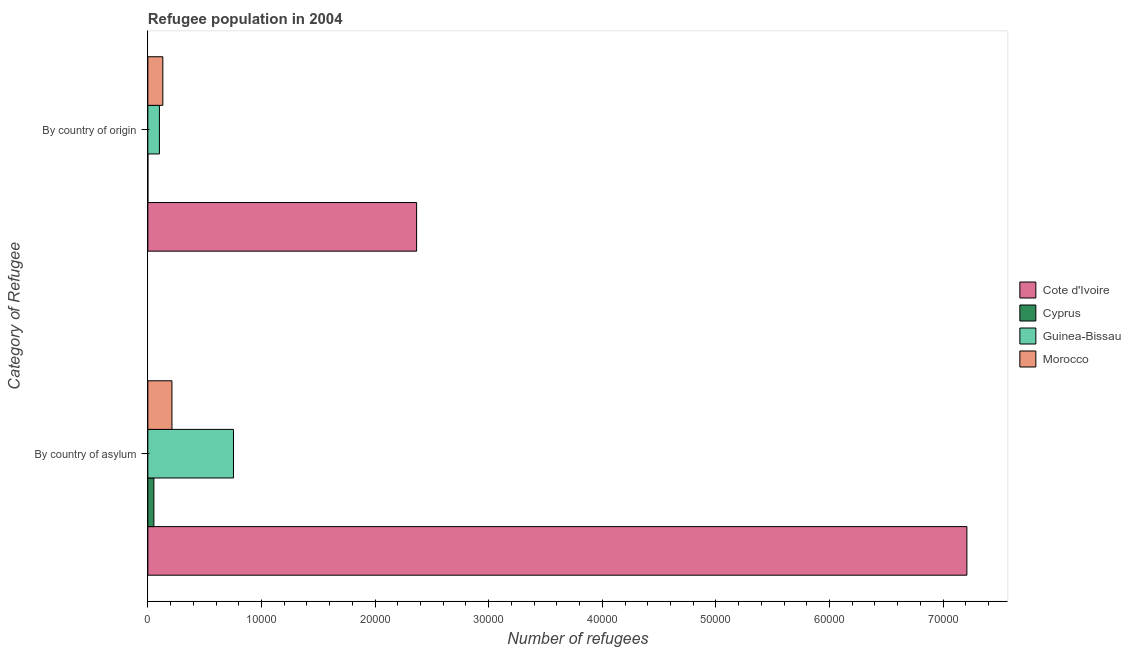How many groups of bars are there?
Keep it short and to the point. 2. What is the label of the 2nd group of bars from the top?
Give a very brief answer. By country of asylum. What is the number of refugees by country of origin in Guinea-Bissau?
Provide a succinct answer. 1018. Across all countries, what is the maximum number of refugees by country of origin?
Your answer should be very brief. 2.37e+04. Across all countries, what is the minimum number of refugees by country of asylum?
Give a very brief answer. 531. In which country was the number of refugees by country of origin maximum?
Your response must be concise. Cote d'Ivoire. In which country was the number of refugees by country of origin minimum?
Your answer should be compact. Cyprus. What is the total number of refugees by country of asylum in the graph?
Make the answer very short. 8.23e+04. What is the difference between the number of refugees by country of asylum in Morocco and that in Guinea-Bissau?
Keep it short and to the point. -5415. What is the difference between the number of refugees by country of asylum in Cyprus and the number of refugees by country of origin in Cote d'Ivoire?
Give a very brief answer. -2.31e+04. What is the average number of refugees by country of origin per country?
Make the answer very short. 6498.5. What is the difference between the number of refugees by country of origin and number of refugees by country of asylum in Guinea-Bissau?
Offer a terse response. -6518. What is the ratio of the number of refugees by country of origin in Cyprus to that in Morocco?
Make the answer very short. 0. Is the number of refugees by country of origin in Cote d'Ivoire less than that in Morocco?
Keep it short and to the point. No. In how many countries, is the number of refugees by country of origin greater than the average number of refugees by country of origin taken over all countries?
Give a very brief answer. 1. What does the 3rd bar from the top in By country of origin represents?
Offer a very short reply. Cyprus. What does the 3rd bar from the bottom in By country of asylum represents?
Provide a short and direct response. Guinea-Bissau. Does the graph contain any zero values?
Ensure brevity in your answer.  No. How many legend labels are there?
Offer a terse response. 4. What is the title of the graph?
Your answer should be very brief. Refugee population in 2004. Does "North America" appear as one of the legend labels in the graph?
Keep it short and to the point. No. What is the label or title of the X-axis?
Provide a short and direct response. Number of refugees. What is the label or title of the Y-axis?
Provide a short and direct response. Category of Refugee. What is the Number of refugees of Cote d'Ivoire in By country of asylum?
Offer a very short reply. 7.21e+04. What is the Number of refugees of Cyprus in By country of asylum?
Offer a very short reply. 531. What is the Number of refugees in Guinea-Bissau in By country of asylum?
Keep it short and to the point. 7536. What is the Number of refugees in Morocco in By country of asylum?
Provide a short and direct response. 2121. What is the Number of refugees of Cote d'Ivoire in By country of origin?
Ensure brevity in your answer.  2.37e+04. What is the Number of refugees in Guinea-Bissau in By country of origin?
Offer a very short reply. 1018. What is the Number of refugees of Morocco in By country of origin?
Your answer should be compact. 1319. Across all Category of Refugee, what is the maximum Number of refugees of Cote d'Ivoire?
Provide a succinct answer. 7.21e+04. Across all Category of Refugee, what is the maximum Number of refugees in Cyprus?
Offer a terse response. 531. Across all Category of Refugee, what is the maximum Number of refugees of Guinea-Bissau?
Ensure brevity in your answer.  7536. Across all Category of Refugee, what is the maximum Number of refugees in Morocco?
Provide a short and direct response. 2121. Across all Category of Refugee, what is the minimum Number of refugees of Cote d'Ivoire?
Your response must be concise. 2.37e+04. Across all Category of Refugee, what is the minimum Number of refugees of Guinea-Bissau?
Offer a very short reply. 1018. Across all Category of Refugee, what is the minimum Number of refugees of Morocco?
Your answer should be compact. 1319. What is the total Number of refugees in Cote d'Ivoire in the graph?
Make the answer very short. 9.57e+04. What is the total Number of refugees of Cyprus in the graph?
Your answer should be compact. 533. What is the total Number of refugees in Guinea-Bissau in the graph?
Provide a succinct answer. 8554. What is the total Number of refugees in Morocco in the graph?
Your answer should be compact. 3440. What is the difference between the Number of refugees in Cote d'Ivoire in By country of asylum and that in By country of origin?
Your response must be concise. 4.84e+04. What is the difference between the Number of refugees of Cyprus in By country of asylum and that in By country of origin?
Offer a terse response. 529. What is the difference between the Number of refugees of Guinea-Bissau in By country of asylum and that in By country of origin?
Offer a very short reply. 6518. What is the difference between the Number of refugees in Morocco in By country of asylum and that in By country of origin?
Give a very brief answer. 802. What is the difference between the Number of refugees in Cote d'Ivoire in By country of asylum and the Number of refugees in Cyprus in By country of origin?
Keep it short and to the point. 7.21e+04. What is the difference between the Number of refugees of Cote d'Ivoire in By country of asylum and the Number of refugees of Guinea-Bissau in By country of origin?
Provide a succinct answer. 7.11e+04. What is the difference between the Number of refugees in Cote d'Ivoire in By country of asylum and the Number of refugees in Morocco in By country of origin?
Offer a very short reply. 7.08e+04. What is the difference between the Number of refugees of Cyprus in By country of asylum and the Number of refugees of Guinea-Bissau in By country of origin?
Provide a short and direct response. -487. What is the difference between the Number of refugees of Cyprus in By country of asylum and the Number of refugees of Morocco in By country of origin?
Provide a succinct answer. -788. What is the difference between the Number of refugees of Guinea-Bissau in By country of asylum and the Number of refugees of Morocco in By country of origin?
Offer a terse response. 6217. What is the average Number of refugees of Cote d'Ivoire per Category of Refugee?
Provide a short and direct response. 4.79e+04. What is the average Number of refugees of Cyprus per Category of Refugee?
Provide a succinct answer. 266.5. What is the average Number of refugees of Guinea-Bissau per Category of Refugee?
Keep it short and to the point. 4277. What is the average Number of refugees in Morocco per Category of Refugee?
Give a very brief answer. 1720. What is the difference between the Number of refugees of Cote d'Ivoire and Number of refugees of Cyprus in By country of asylum?
Make the answer very short. 7.16e+04. What is the difference between the Number of refugees in Cote d'Ivoire and Number of refugees in Guinea-Bissau in By country of asylum?
Ensure brevity in your answer.  6.46e+04. What is the difference between the Number of refugees of Cote d'Ivoire and Number of refugees of Morocco in By country of asylum?
Your answer should be compact. 7.00e+04. What is the difference between the Number of refugees of Cyprus and Number of refugees of Guinea-Bissau in By country of asylum?
Offer a very short reply. -7005. What is the difference between the Number of refugees of Cyprus and Number of refugees of Morocco in By country of asylum?
Offer a terse response. -1590. What is the difference between the Number of refugees in Guinea-Bissau and Number of refugees in Morocco in By country of asylum?
Offer a terse response. 5415. What is the difference between the Number of refugees of Cote d'Ivoire and Number of refugees of Cyprus in By country of origin?
Make the answer very short. 2.37e+04. What is the difference between the Number of refugees in Cote d'Ivoire and Number of refugees in Guinea-Bissau in By country of origin?
Offer a very short reply. 2.26e+04. What is the difference between the Number of refugees in Cote d'Ivoire and Number of refugees in Morocco in By country of origin?
Make the answer very short. 2.23e+04. What is the difference between the Number of refugees in Cyprus and Number of refugees in Guinea-Bissau in By country of origin?
Ensure brevity in your answer.  -1016. What is the difference between the Number of refugees of Cyprus and Number of refugees of Morocco in By country of origin?
Ensure brevity in your answer.  -1317. What is the difference between the Number of refugees of Guinea-Bissau and Number of refugees of Morocco in By country of origin?
Make the answer very short. -301. What is the ratio of the Number of refugees of Cote d'Ivoire in By country of asylum to that in By country of origin?
Offer a terse response. 3.05. What is the ratio of the Number of refugees of Cyprus in By country of asylum to that in By country of origin?
Make the answer very short. 265.5. What is the ratio of the Number of refugees in Guinea-Bissau in By country of asylum to that in By country of origin?
Ensure brevity in your answer.  7.4. What is the ratio of the Number of refugees of Morocco in By country of asylum to that in By country of origin?
Your answer should be compact. 1.61. What is the difference between the highest and the second highest Number of refugees in Cote d'Ivoire?
Offer a very short reply. 4.84e+04. What is the difference between the highest and the second highest Number of refugees in Cyprus?
Your answer should be very brief. 529. What is the difference between the highest and the second highest Number of refugees in Guinea-Bissau?
Give a very brief answer. 6518. What is the difference between the highest and the second highest Number of refugees of Morocco?
Provide a succinct answer. 802. What is the difference between the highest and the lowest Number of refugees in Cote d'Ivoire?
Provide a succinct answer. 4.84e+04. What is the difference between the highest and the lowest Number of refugees of Cyprus?
Provide a succinct answer. 529. What is the difference between the highest and the lowest Number of refugees of Guinea-Bissau?
Keep it short and to the point. 6518. What is the difference between the highest and the lowest Number of refugees of Morocco?
Give a very brief answer. 802. 